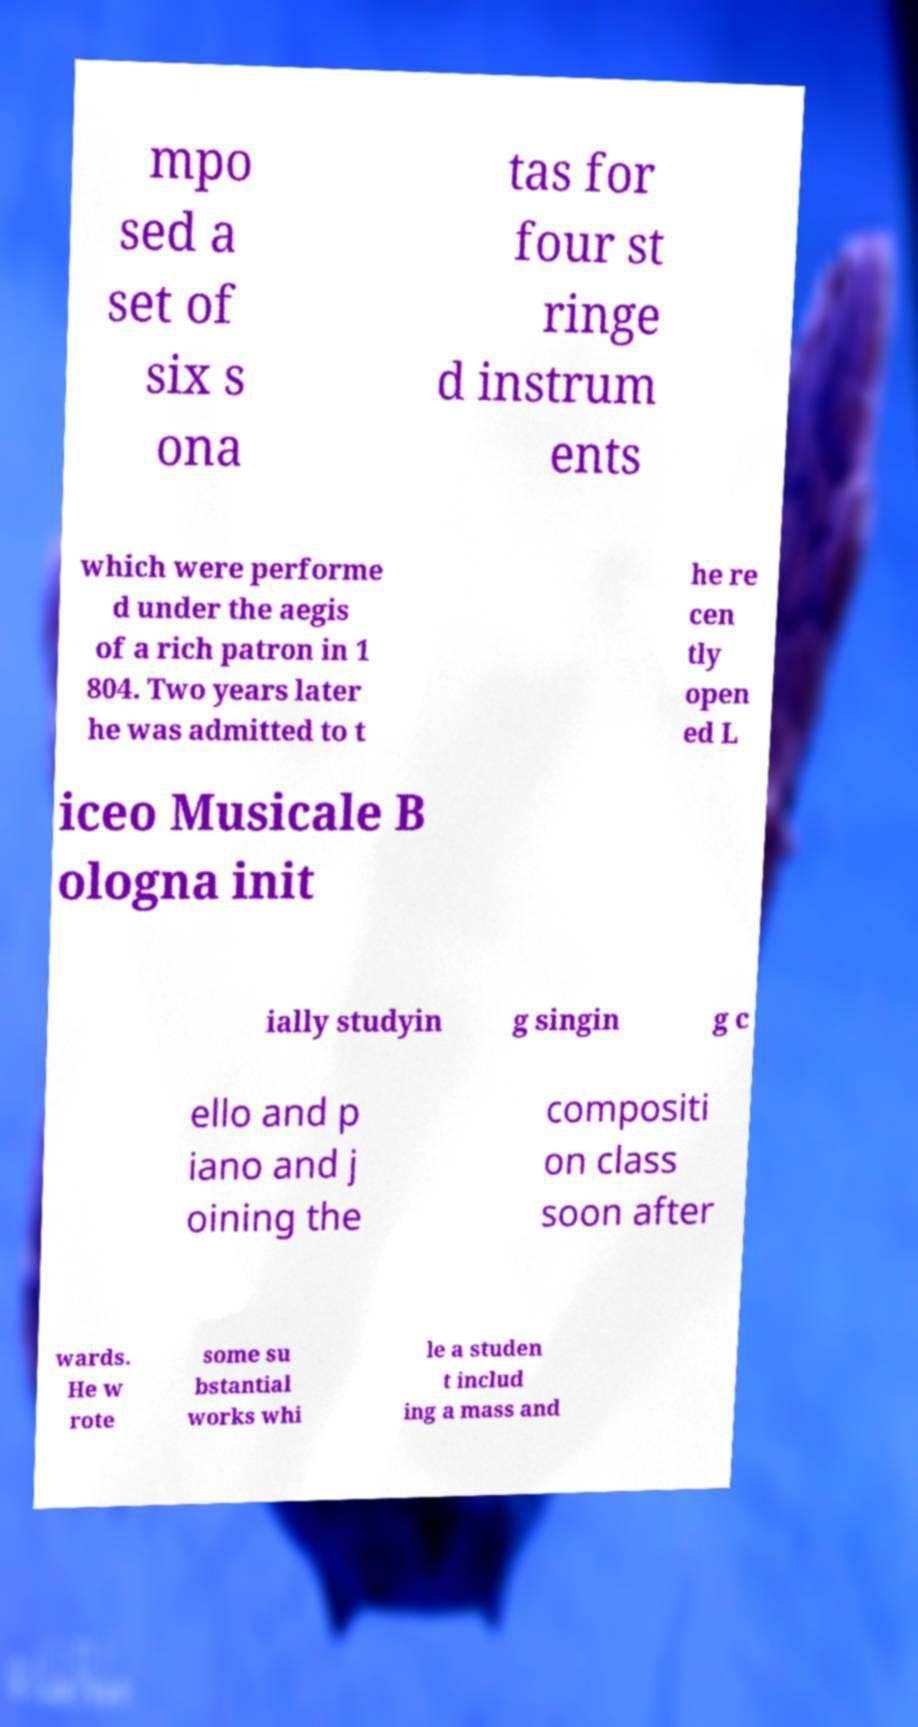For documentation purposes, I need the text within this image transcribed. Could you provide that? mpo sed a set of six s ona tas for four st ringe d instrum ents which were performe d under the aegis of a rich patron in 1 804. Two years later he was admitted to t he re cen tly open ed L iceo Musicale B ologna init ially studyin g singin g c ello and p iano and j oining the compositi on class soon after wards. He w rote some su bstantial works whi le a studen t includ ing a mass and 